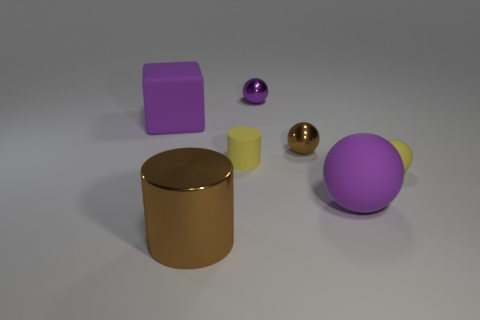Add 2 tiny brown objects. How many objects exist? 9 Subtract all cylinders. How many objects are left? 5 Subtract 0 blue spheres. How many objects are left? 7 Subtract all small brown things. Subtract all metal cylinders. How many objects are left? 5 Add 5 big balls. How many big balls are left? 6 Add 4 big red things. How many big red things exist? 4 